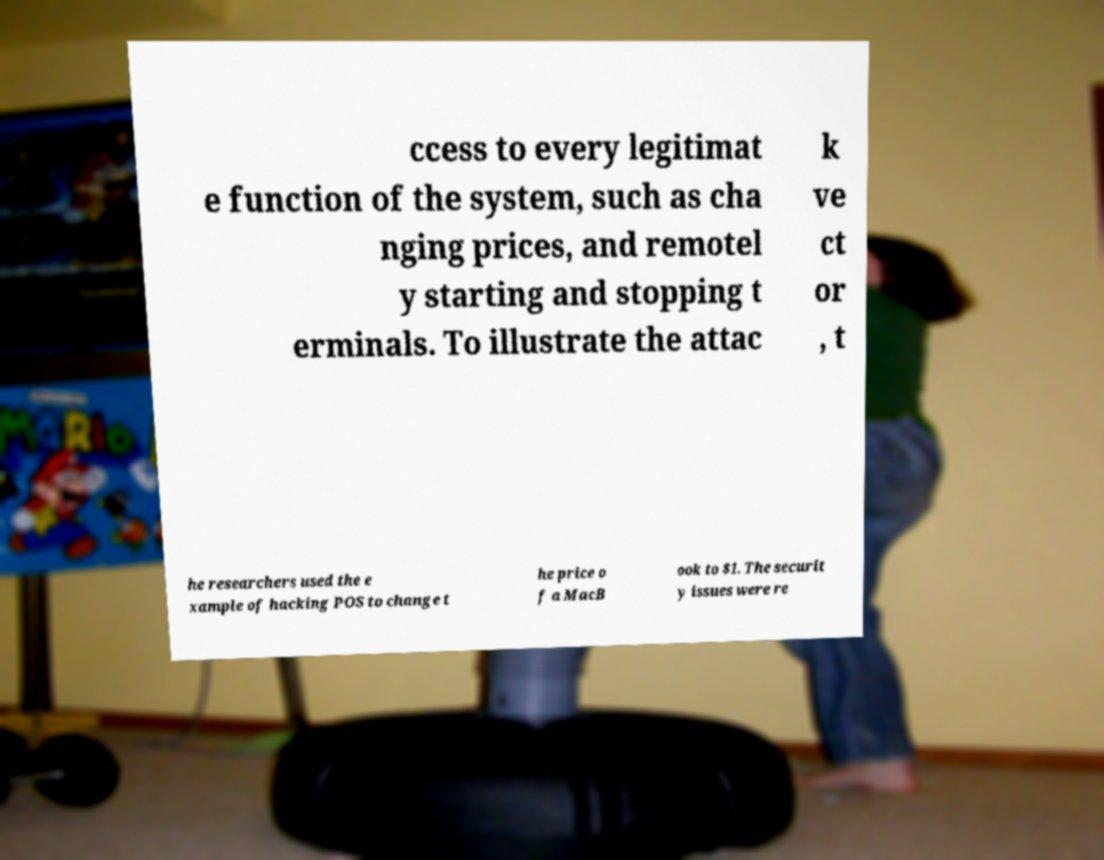For documentation purposes, I need the text within this image transcribed. Could you provide that? ccess to every legitimat e function of the system, such as cha nging prices, and remotel y starting and stopping t erminals. To illustrate the attac k ve ct or , t he researchers used the e xample of hacking POS to change t he price o f a MacB ook to $1. The securit y issues were re 